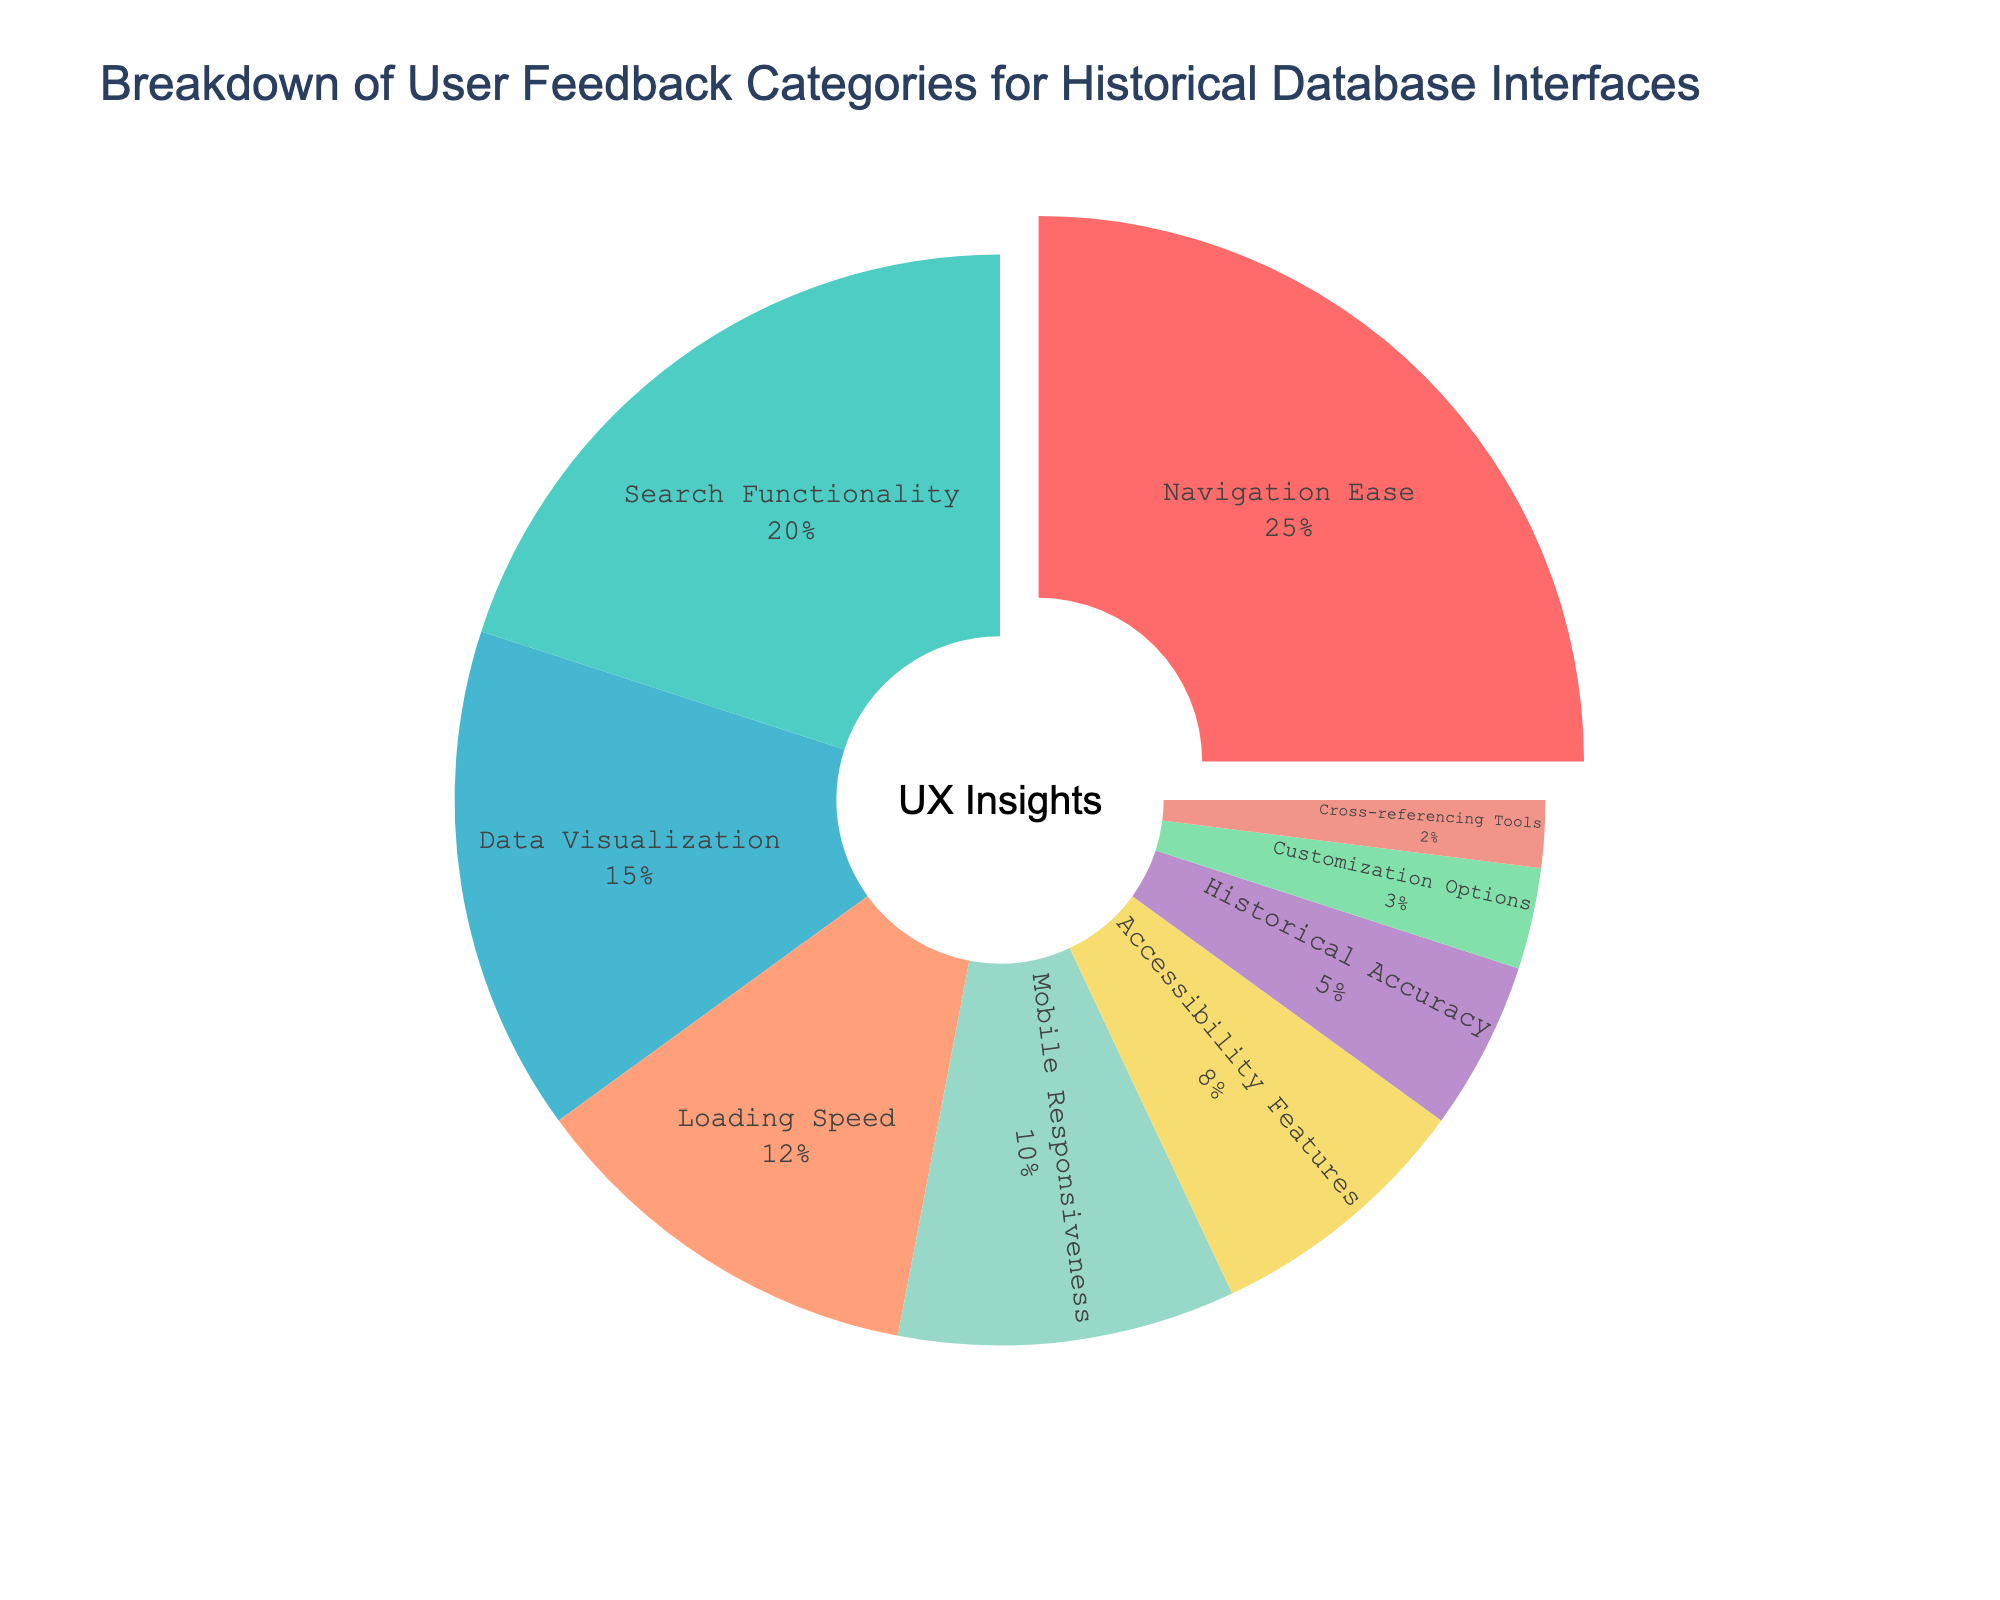What's the category with the highest user feedback percentage? First, identify the segment with the highest percentage. Navigation Ease has 25%, which is higher than any other category.
Answer: Navigation Ease Which category has a smaller percentage than Data Visualization but larger than Accessibility Features? Data Visualization is at 15%, and Accessibility Features is at 8%. The categories in between are Loading Speed (12%) and Mobile Responsiveness (10%).
Answer: Loading Speed, Mobile Responsiveness What is the sum of the percentages for Navigation Ease and Search Functionality? Navigation Ease is 25%, and Search Functionality is 20%. Summing them gives 25% + 20% = 45%.
Answer: 45% Which category has the smallest user feedback percentage? Identify the segment with the smallest percentage. Cross-referencing Tools has the smallest at 2%.
Answer: Cross-referencing Tools What is the combined percentage of the three categories with the least user feedback percentages? Cross-referencing Tools (2%), Customization Options (3%), and Historical Accuracy (5%) are the three categories with the least percentages. Summing them gives 2% + 3% + 5% = 10%.
Answer: 10% Is Data Visualization's feedback percentage greater than Historical Accuracy's by more than 5%? Data Visualization is at 15%, and Historical Accuracy is at 5%. The difference is 15% - 5% = 10%, which is more than 5%.
Answer: Yes Which category is represented by a light green color? From the listed colors in the code and the visual attributes, Data Visualization is represented by a light green color.
Answer: Data Visualization What's the difference between the percentage of Accessibility Features and Customization Options? Accessibility Features is at 8%, and Customization Options is at 3%. The difference is 8% - 3% = 5%.
Answer: 5% What percentage represents Mobile Responsiveness in the user feedback? Identify the percentage corresponding to Mobile Responsiveness in the chart. It is 10%.
Answer: 10% 